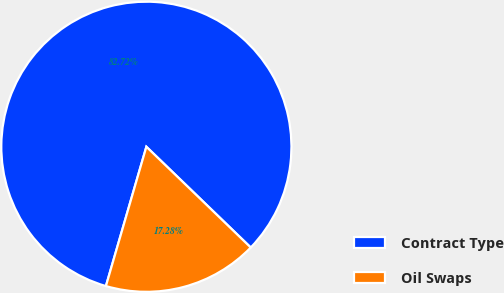<chart> <loc_0><loc_0><loc_500><loc_500><pie_chart><fcel>Contract Type<fcel>Oil Swaps<nl><fcel>82.72%<fcel>17.28%<nl></chart> 